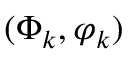Convert formula to latex. <formula><loc_0><loc_0><loc_500><loc_500>( \Phi _ { k } , \varphi _ { k } )</formula> 